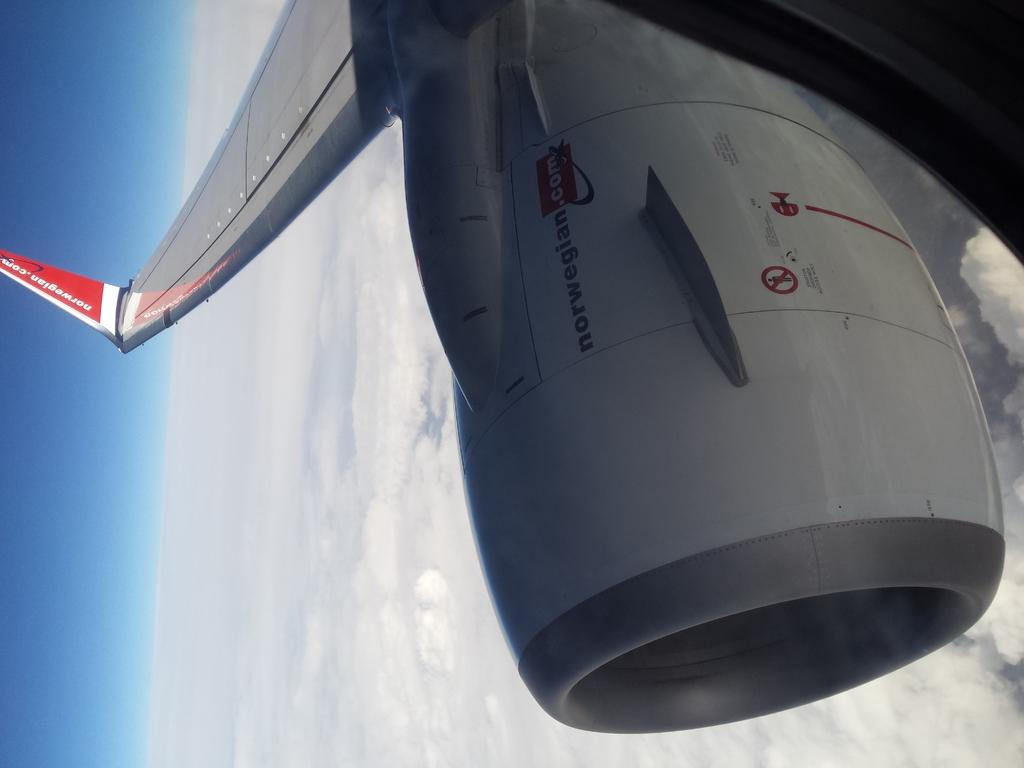Provide a one-sentence caption for the provided image. A plane flying above the clouds with norwegian.com on its tail and engine. 